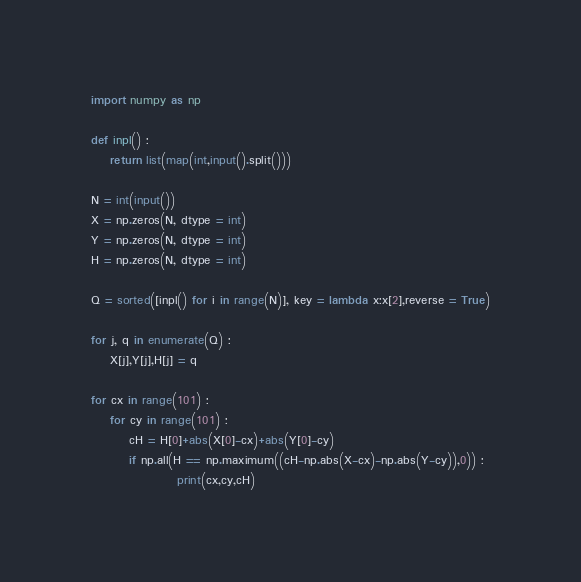Convert code to text. <code><loc_0><loc_0><loc_500><loc_500><_Python_>import numpy as np

def inpl() :
    return list(map(int,input().split()))

N = int(input())
X = np.zeros(N, dtype = int)
Y = np.zeros(N, dtype = int)
H = np.zeros(N, dtype = int)

Q = sorted([inpl() for i in range(N)], key = lambda x:x[2],reverse = True)

for j, q in enumerate(Q) :
    X[j],Y[j],H[j] = q

for cx in range(101) :
    for cy in range(101) :
        cH = H[0]+abs(X[0]-cx)+abs(Y[0]-cy)
        if np.all(H == np.maximum((cH-np.abs(X-cx)-np.abs(Y-cy)),0)) :
                  print(cx,cy,cH)
</code> 